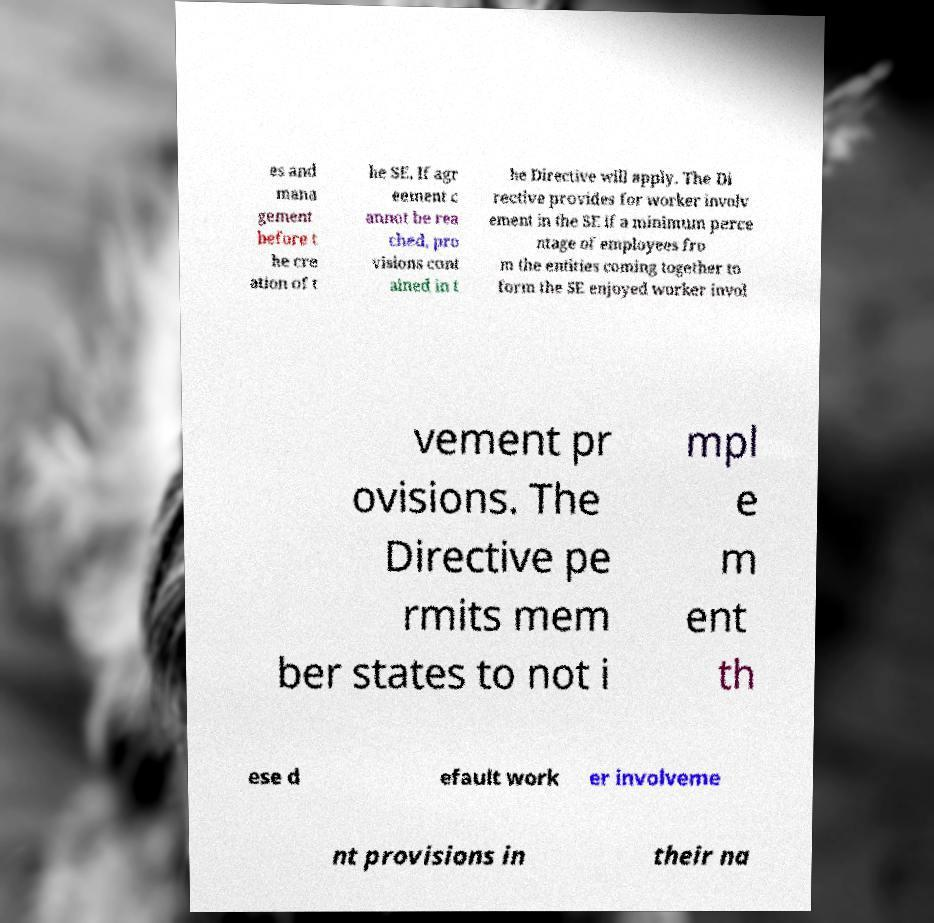There's text embedded in this image that I need extracted. Can you transcribe it verbatim? es and mana gement before t he cre ation of t he SE. If agr eement c annot be rea ched, pro visions cont ained in t he Directive will apply. The Di rective provides for worker involv ement in the SE if a minimum perce ntage of employees fro m the entities coming together to form the SE enjoyed worker invol vement pr ovisions. The Directive pe rmits mem ber states to not i mpl e m ent th ese d efault work er involveme nt provisions in their na 